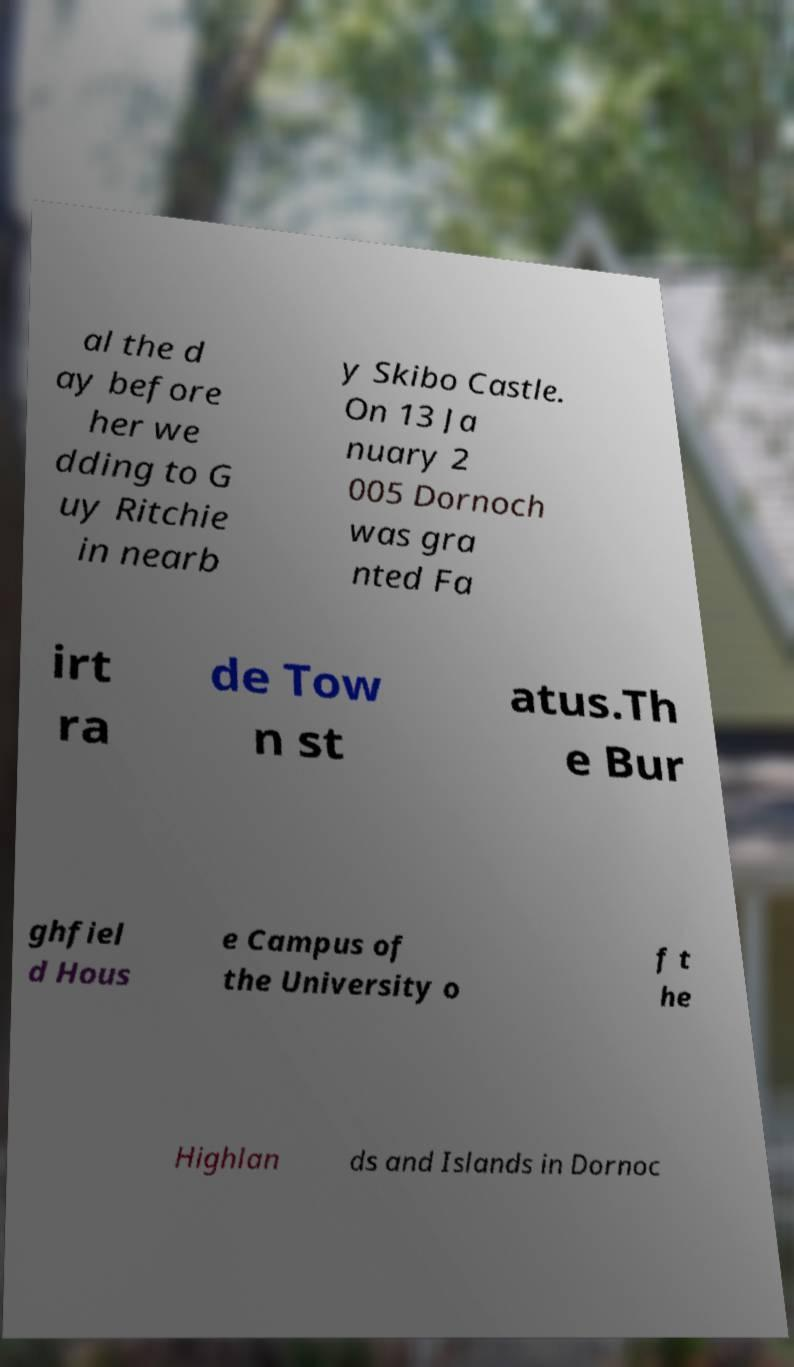For documentation purposes, I need the text within this image transcribed. Could you provide that? al the d ay before her we dding to G uy Ritchie in nearb y Skibo Castle. On 13 Ja nuary 2 005 Dornoch was gra nted Fa irt ra de Tow n st atus.Th e Bur ghfiel d Hous e Campus of the University o f t he Highlan ds and Islands in Dornoc 